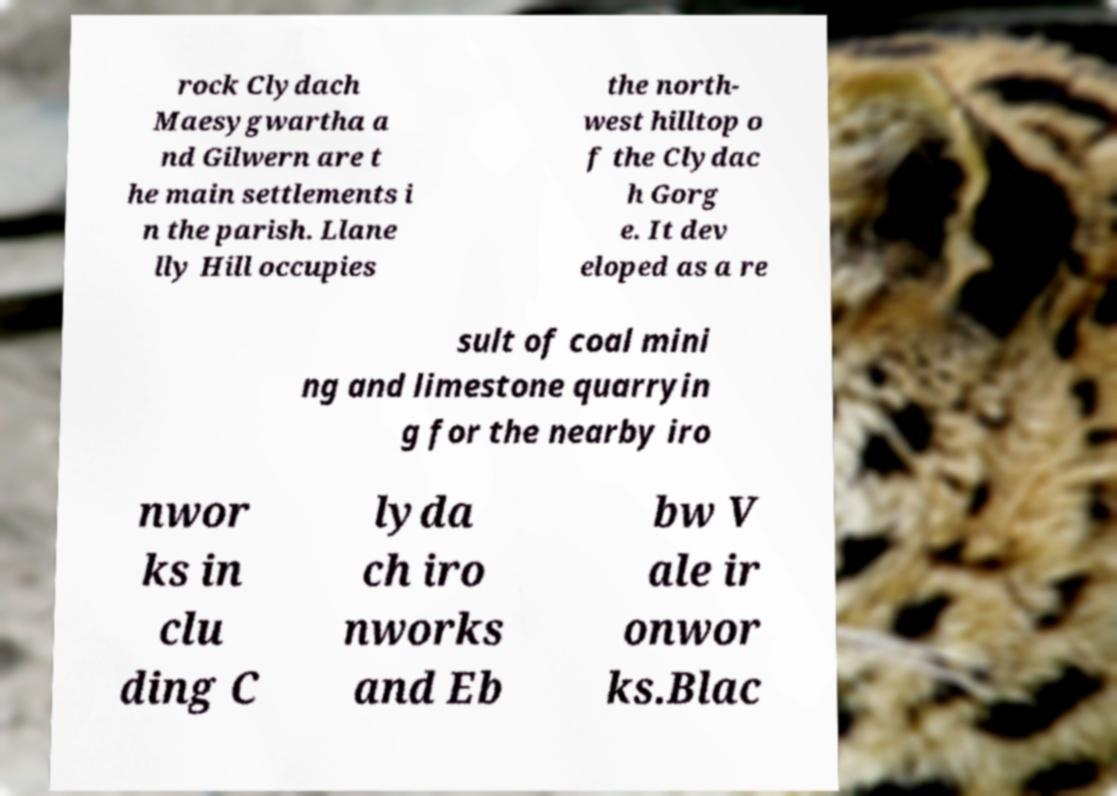Could you assist in decoding the text presented in this image and type it out clearly? rock Clydach Maesygwartha a nd Gilwern are t he main settlements i n the parish. Llane lly Hill occupies the north- west hilltop o f the Clydac h Gorg e. It dev eloped as a re sult of coal mini ng and limestone quarryin g for the nearby iro nwor ks in clu ding C lyda ch iro nworks and Eb bw V ale ir onwor ks.Blac 